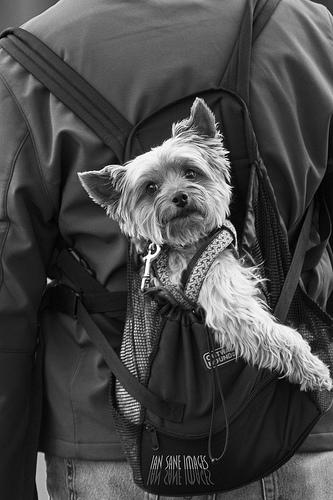Question: what is in the bag?
Choices:
A. Cat.
B. Dog.
C. Fish.
D. Kitten.
Answer with the letter. Answer: B Question: why is the dog in the bag?
Choices:
A. Sleeping.
B. Carry.
C. Hiding.
D. Being shy.
Answer with the letter. Answer: B Question: what does the dog use to sniff?
Choices:
A. Butt.
B. Nose.
C. Ears.
D. Paws.
Answer with the letter. Answer: B Question: where is the bag?
Choices:
A. On the ground.
B. In the persons hand.
C. Persons back.
D. On the persons shoulder.
Answer with the letter. Answer: C 